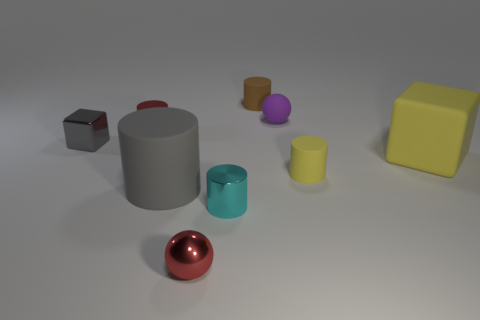There is a big object on the left side of the small red metallic object in front of the red shiny cylinder; what is its shape?
Offer a very short reply. Cylinder. There is a tiny purple object that is behind the gray block; does it have the same shape as the large gray object?
Your answer should be very brief. No. There is a tiny matte cylinder that is on the right side of the small matte sphere; what is its color?
Ensure brevity in your answer.  Yellow. What number of cylinders are either red things or metallic objects?
Provide a succinct answer. 2. There is a ball that is behind the rubber cylinder on the right side of the tiny brown rubber cylinder; what is its size?
Ensure brevity in your answer.  Small. Do the tiny matte ball and the small rubber cylinder that is behind the small cube have the same color?
Your answer should be compact. No. There is a large yellow object; how many big yellow rubber cubes are on the left side of it?
Provide a succinct answer. 0. Is the number of brown matte cylinders less than the number of shiny cylinders?
Offer a very short reply. Yes. What size is the cylinder that is both behind the shiny block and on the right side of the tiny red cylinder?
Offer a terse response. Small. Do the metal cylinder in front of the yellow rubber cylinder and the large rubber cylinder have the same color?
Provide a succinct answer. No. 